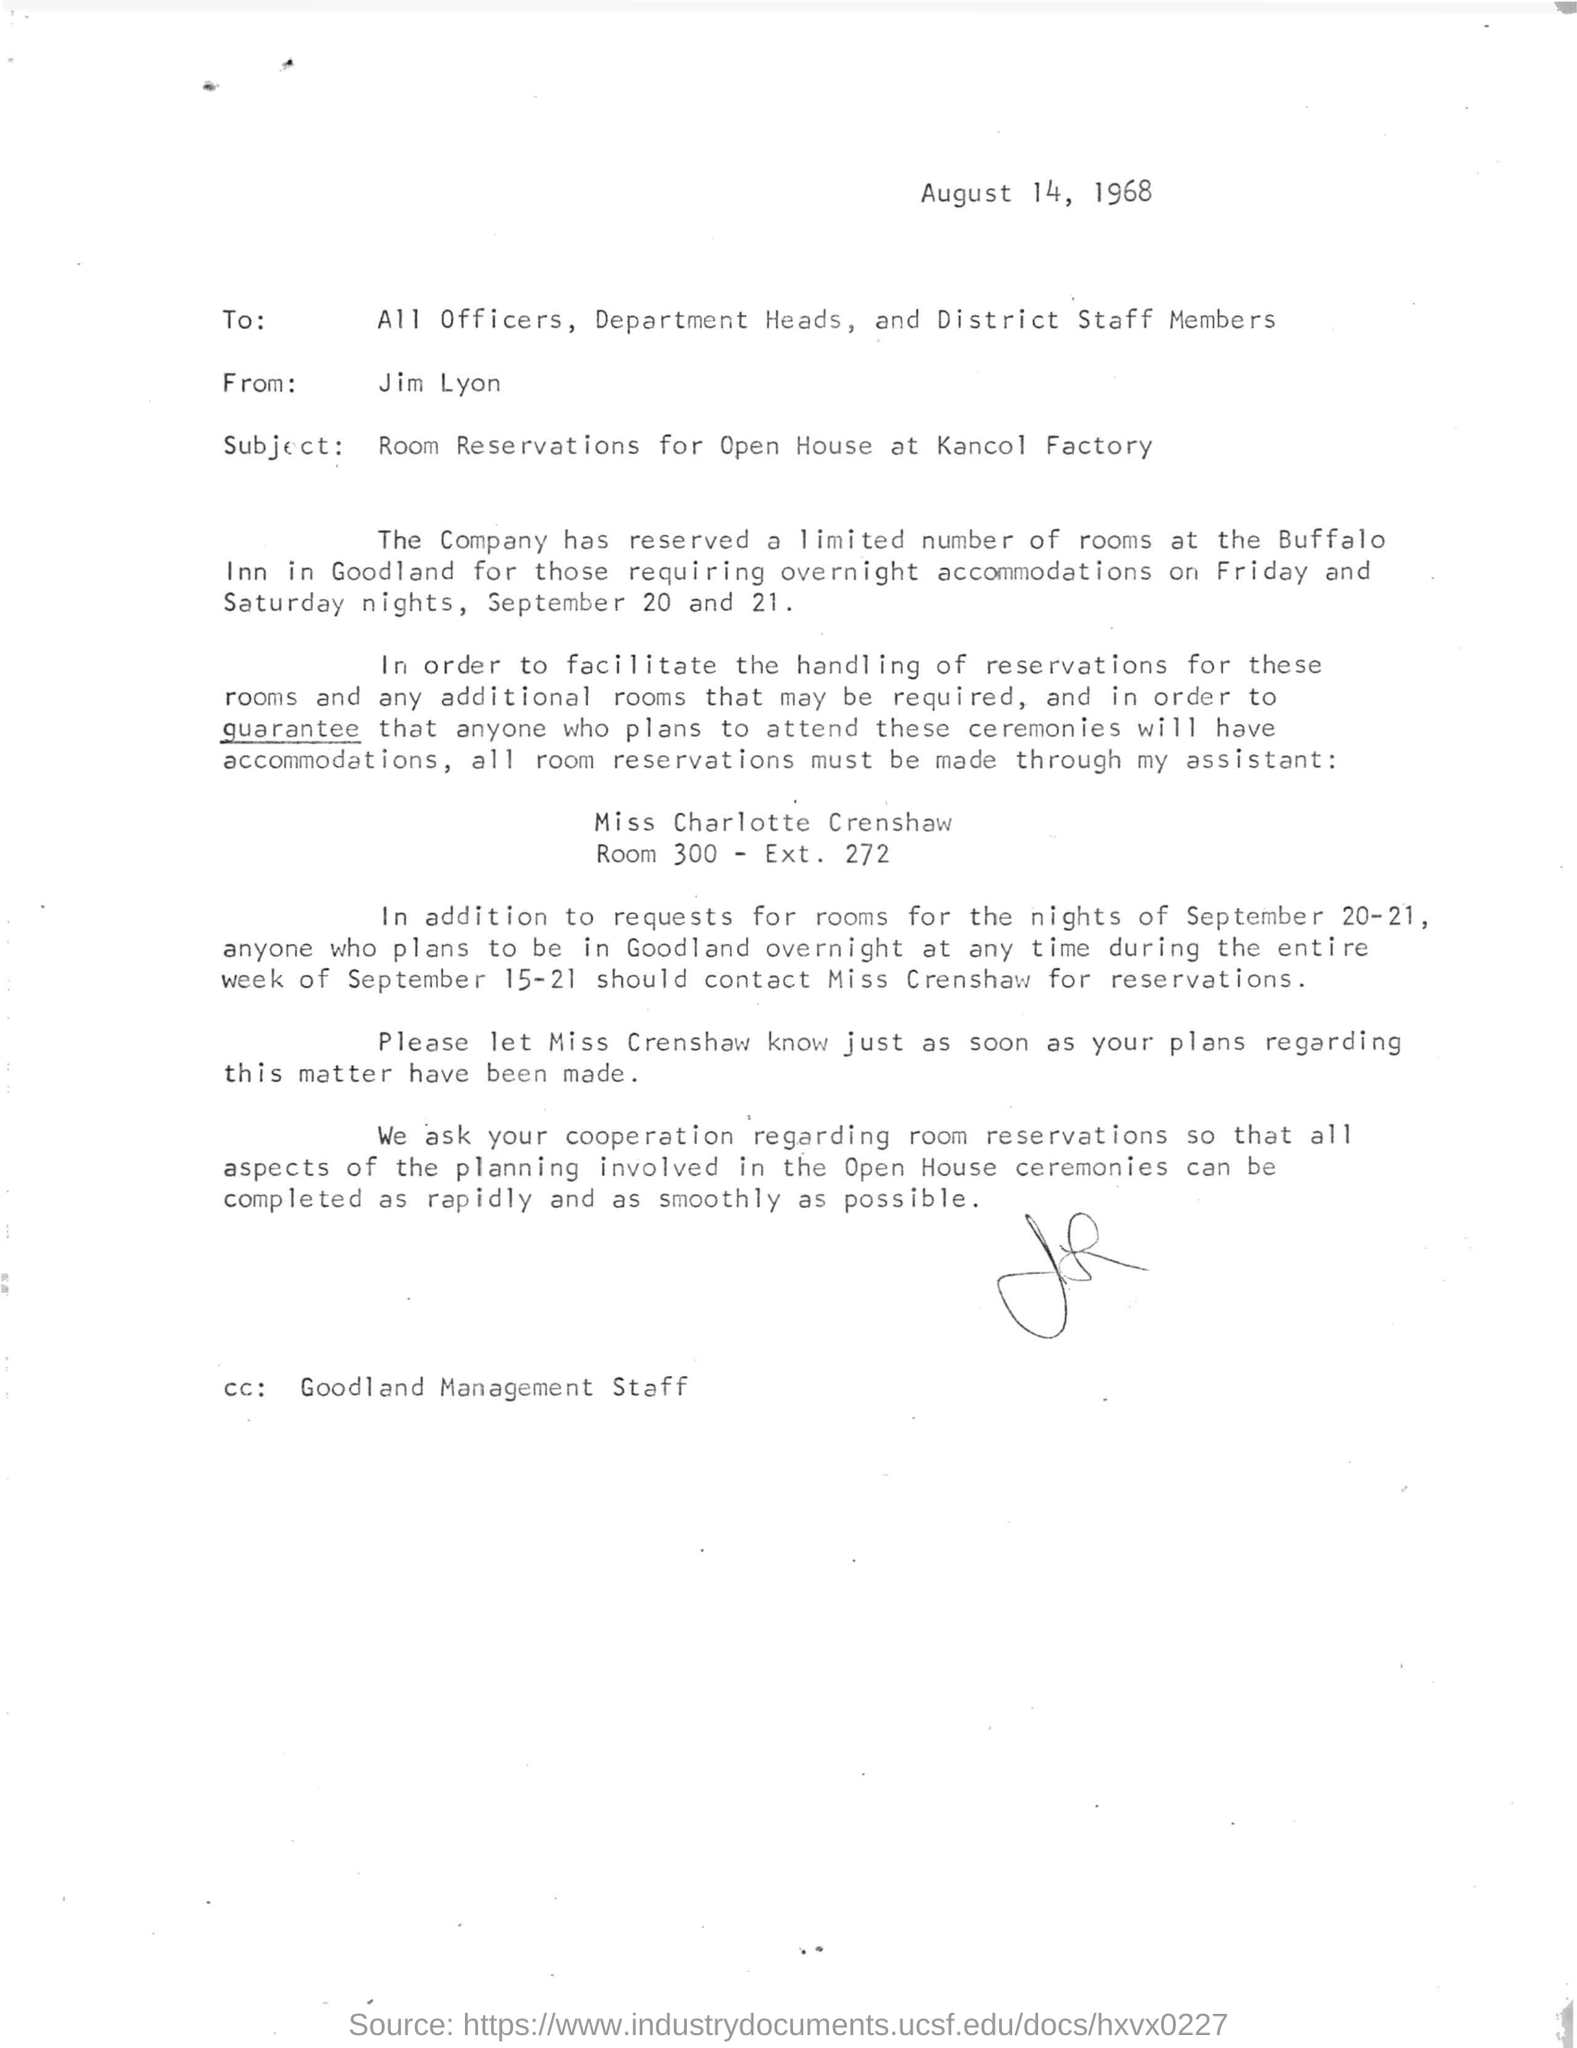Outline some significant characteristics in this image. The letter is dated August 14, 1968. 